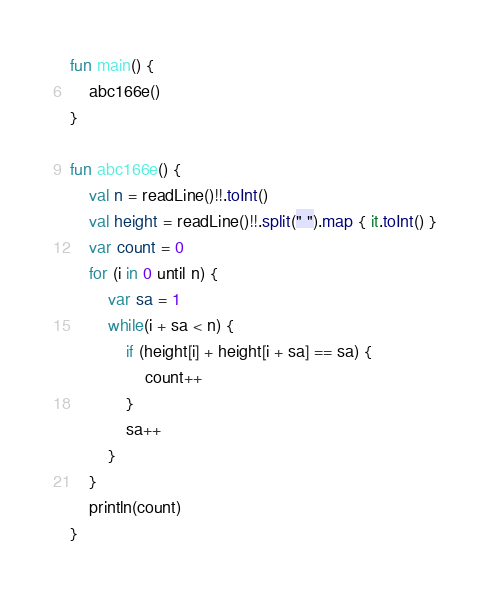<code> <loc_0><loc_0><loc_500><loc_500><_Kotlin_>fun main() {
    abc166e()
}

fun abc166e() {
    val n = readLine()!!.toInt()
    val height = readLine()!!.split(" ").map { it.toInt() }
    var count = 0
    for (i in 0 until n) {
        var sa = 1
        while(i + sa < n) {
            if (height[i] + height[i + sa] == sa) {
                count++
            }
            sa++
        }
    }
    println(count)
}</code> 